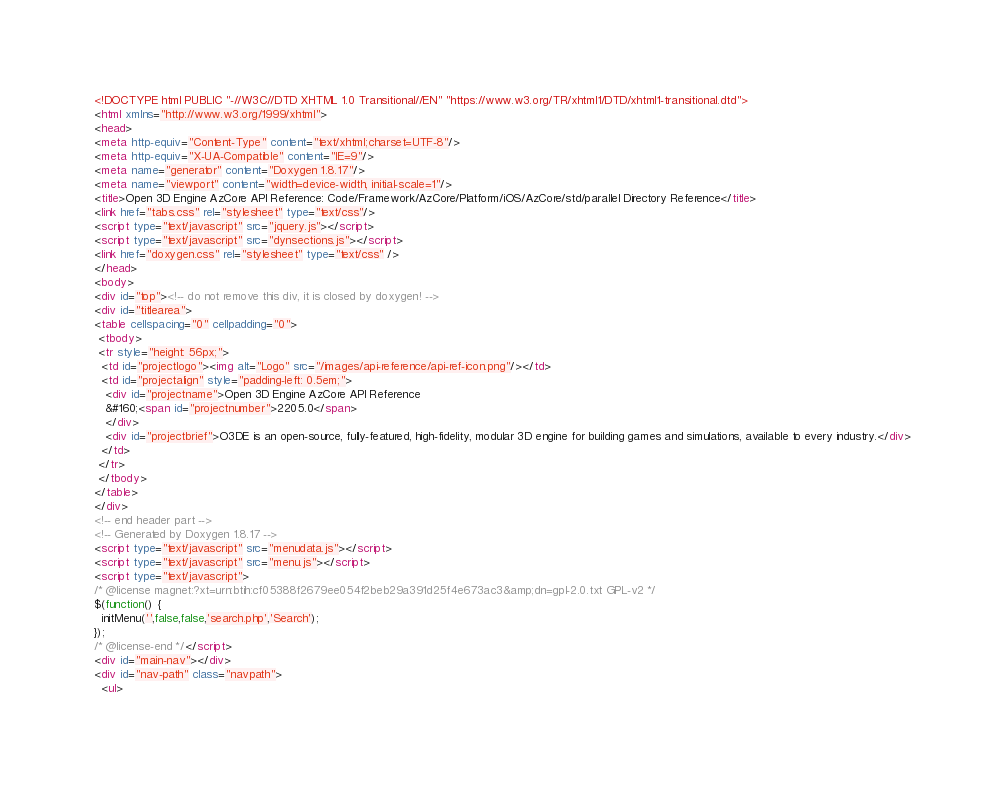Convert code to text. <code><loc_0><loc_0><loc_500><loc_500><_HTML_><!DOCTYPE html PUBLIC "-//W3C//DTD XHTML 1.0 Transitional//EN" "https://www.w3.org/TR/xhtml1/DTD/xhtml1-transitional.dtd">
<html xmlns="http://www.w3.org/1999/xhtml">
<head>
<meta http-equiv="Content-Type" content="text/xhtml;charset=UTF-8"/>
<meta http-equiv="X-UA-Compatible" content="IE=9"/>
<meta name="generator" content="Doxygen 1.8.17"/>
<meta name="viewport" content="width=device-width, initial-scale=1"/>
<title>Open 3D Engine AzCore API Reference: Code/Framework/AzCore/Platform/iOS/AzCore/std/parallel Directory Reference</title>
<link href="tabs.css" rel="stylesheet" type="text/css"/>
<script type="text/javascript" src="jquery.js"></script>
<script type="text/javascript" src="dynsections.js"></script>
<link href="doxygen.css" rel="stylesheet" type="text/css" />
</head>
<body>
<div id="top"><!-- do not remove this div, it is closed by doxygen! -->
<div id="titlearea">
<table cellspacing="0" cellpadding="0">
 <tbody>
 <tr style="height: 56px;">
  <td id="projectlogo"><img alt="Logo" src="/images/api-reference/api-ref-icon.png"/></td>
  <td id="projectalign" style="padding-left: 0.5em;">
   <div id="projectname">Open 3D Engine AzCore API Reference
   &#160;<span id="projectnumber">2205.0</span>
   </div>
   <div id="projectbrief">O3DE is an open-source, fully-featured, high-fidelity, modular 3D engine for building games and simulations, available to every industry.</div>
  </td>
 </tr>
 </tbody>
</table>
</div>
<!-- end header part -->
<!-- Generated by Doxygen 1.8.17 -->
<script type="text/javascript" src="menudata.js"></script>
<script type="text/javascript" src="menu.js"></script>
<script type="text/javascript">
/* @license magnet:?xt=urn:btih:cf05388f2679ee054f2beb29a391d25f4e673ac3&amp;dn=gpl-2.0.txt GPL-v2 */
$(function() {
  initMenu('',false,false,'search.php','Search');
});
/* @license-end */</script>
<div id="main-nav"></div>
<div id="nav-path" class="navpath">
  <ul></code> 